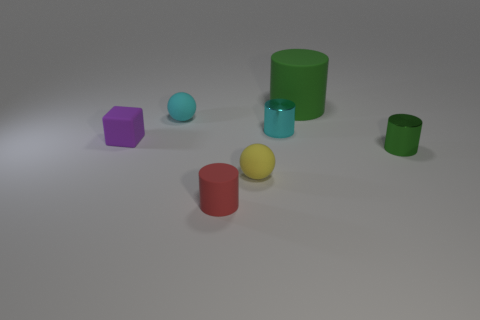Subtract all tiny matte cylinders. How many cylinders are left? 3 Add 1 yellow balls. How many objects exist? 8 Subtract all cylinders. How many objects are left? 3 Subtract all green cylinders. How many cylinders are left? 2 Subtract 1 spheres. How many spheres are left? 1 Subtract all blue spheres. How many green cylinders are left? 2 Add 6 red rubber objects. How many red rubber objects exist? 7 Subtract 2 green cylinders. How many objects are left? 5 Subtract all blue spheres. Subtract all cyan cylinders. How many spheres are left? 2 Subtract all cyan matte things. Subtract all small cyan spheres. How many objects are left? 5 